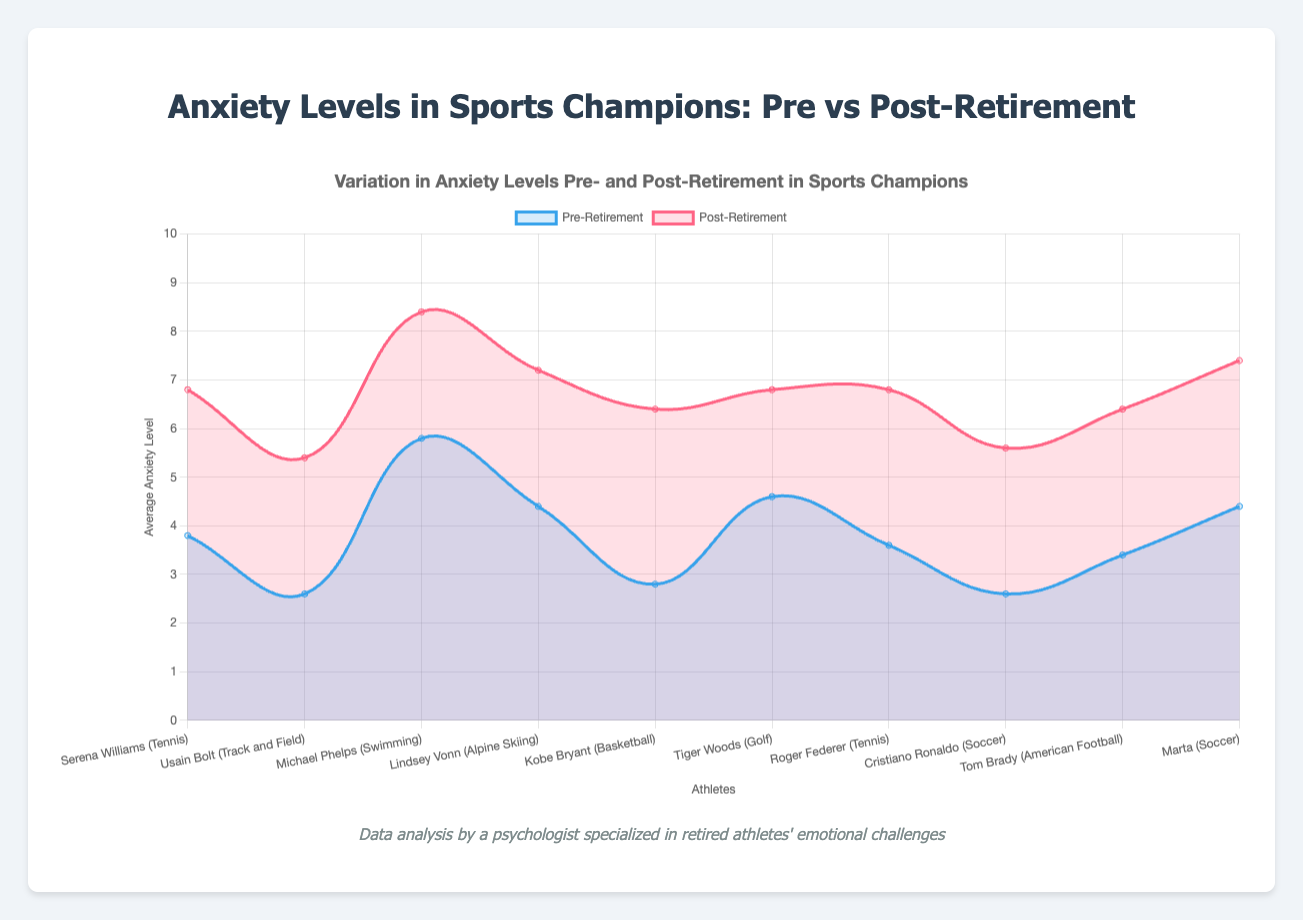What is the average anxiety level of Serena Williams post-retirement? The anxiety levels of Serena Williams post-retirement are [6, 7, 6, 7, 8]. To find the average, sum these values: 6 + 7 + 6 + 7 + 8 = 34, then divide by the number of values (5): 34 / 5 = 6.8
Answer: 6.8 Who has a higher average anxiety level post-retirement, Usain Bolt or Tom Brady? Usain Bolt’s post-retirement anxiety levels are [5, 5, 6, 6, 5], and Tom Brady’s are [6, 6, 7, 6, 7]. Average for Usain Bolt: (5+5+6+6+5)/5 = 5.4. Average for Tom Brady: (6+6+7+6+7)/5 = 6.4. Tom Brady has a higher average anxiety level post-retirement.
Answer: Tom Brady Which athlete shows the largest increase in average anxiety levels from pre- to post-retirement? Calculate the average anxiety levels for each athlete both pre- and post-retirement and find the difference. The athlete with the largest increase is the one with the highest positive difference. Michael Phelps shows an increase from (5.8 to 8.4) = 2.6.
Answer: Michael Phelps What is the average anxiety level of all athletes pre-retirement? Calculate the average pre-retirement anxiety level for each athlete, then average these values. Pre-retirement values: [3.8, 2.6, 5.8, 4.4, 2.8, 4.6, 3.6, 2.6, 3.4, 4.4]. Average: (3.8+2.6+5.8+4.4+2.8+4.6+3.6+2.6+3.4+4.4)/10 = 3.8
Answer: 3.8 How does Michael Phelps' post-retirement anxiety level compare to Serena Williams' pre-retirement anxiety level visually? Michael Phelps' post-retirement line is represented by a higher red line, while Serena Williams' pre-retirement line is a lower blue line. We can visually see that Michael Phelps’ values are significantly higher.
Answer: Higher 